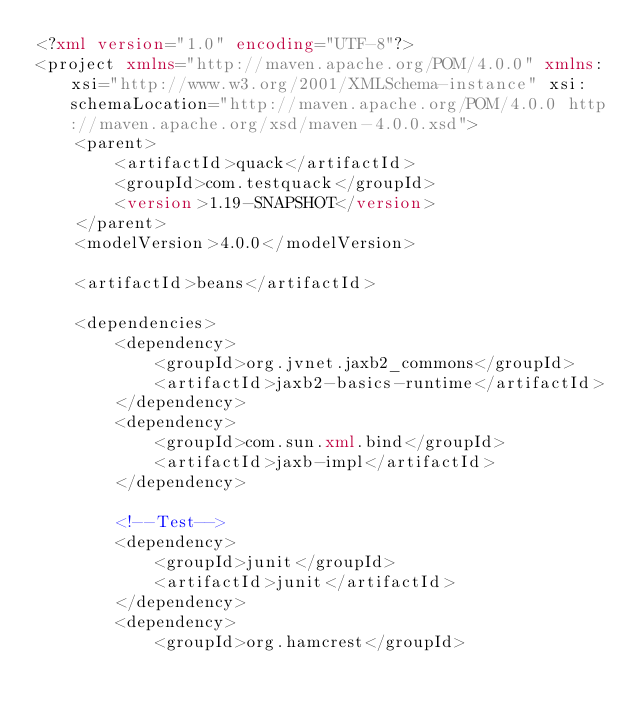Convert code to text. <code><loc_0><loc_0><loc_500><loc_500><_XML_><?xml version="1.0" encoding="UTF-8"?>
<project xmlns="http://maven.apache.org/POM/4.0.0" xmlns:xsi="http://www.w3.org/2001/XMLSchema-instance" xsi:schemaLocation="http://maven.apache.org/POM/4.0.0 http://maven.apache.org/xsd/maven-4.0.0.xsd">
    <parent>
        <artifactId>quack</artifactId>
        <groupId>com.testquack</groupId>
        <version>1.19-SNAPSHOT</version>
    </parent>
    <modelVersion>4.0.0</modelVersion>

    <artifactId>beans</artifactId>

    <dependencies>
        <dependency>
            <groupId>org.jvnet.jaxb2_commons</groupId>
            <artifactId>jaxb2-basics-runtime</artifactId>
        </dependency>
        <dependency>
            <groupId>com.sun.xml.bind</groupId>
            <artifactId>jaxb-impl</artifactId>
        </dependency>

        <!--Test-->
        <dependency>
            <groupId>junit</groupId>
            <artifactId>junit</artifactId>
        </dependency>
        <dependency>
            <groupId>org.hamcrest</groupId></code> 